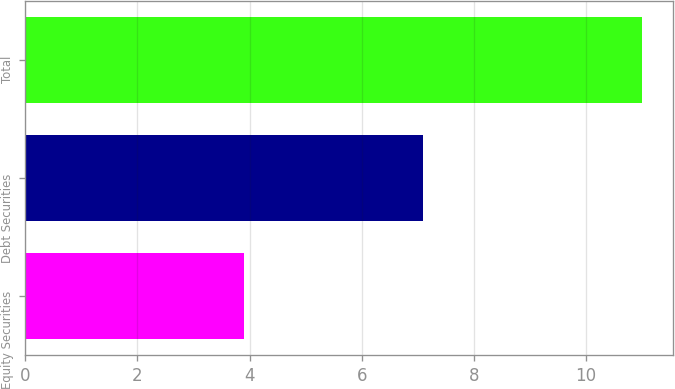Convert chart. <chart><loc_0><loc_0><loc_500><loc_500><bar_chart><fcel>Equity Securities<fcel>Debt Securities<fcel>Total<nl><fcel>3.9<fcel>7.1<fcel>11<nl></chart> 